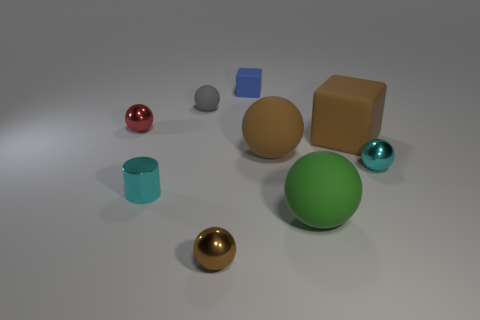Add 1 small red metal cylinders. How many objects exist? 10 Add 2 big spheres. How many big spheres exist? 4 Subtract all brown cubes. How many cubes are left? 1 Subtract all large matte spheres. How many spheres are left? 4 Subtract 0 green blocks. How many objects are left? 9 Subtract all balls. How many objects are left? 3 Subtract 1 balls. How many balls are left? 5 Subtract all yellow cylinders. Subtract all brown blocks. How many cylinders are left? 1 Subtract all green blocks. How many gray spheres are left? 1 Subtract all small gray spheres. Subtract all large matte blocks. How many objects are left? 7 